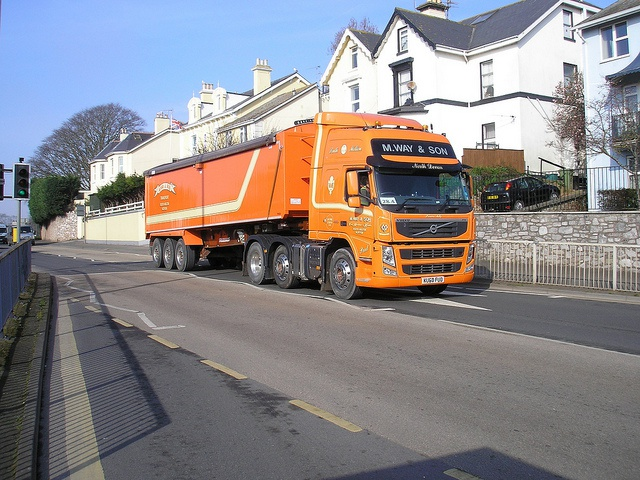Describe the objects in this image and their specific colors. I can see truck in purple, orange, black, and gray tones, car in purple, black, and gray tones, traffic light in purple, black, gray, and teal tones, and car in purple, black, gray, and darkgray tones in this image. 